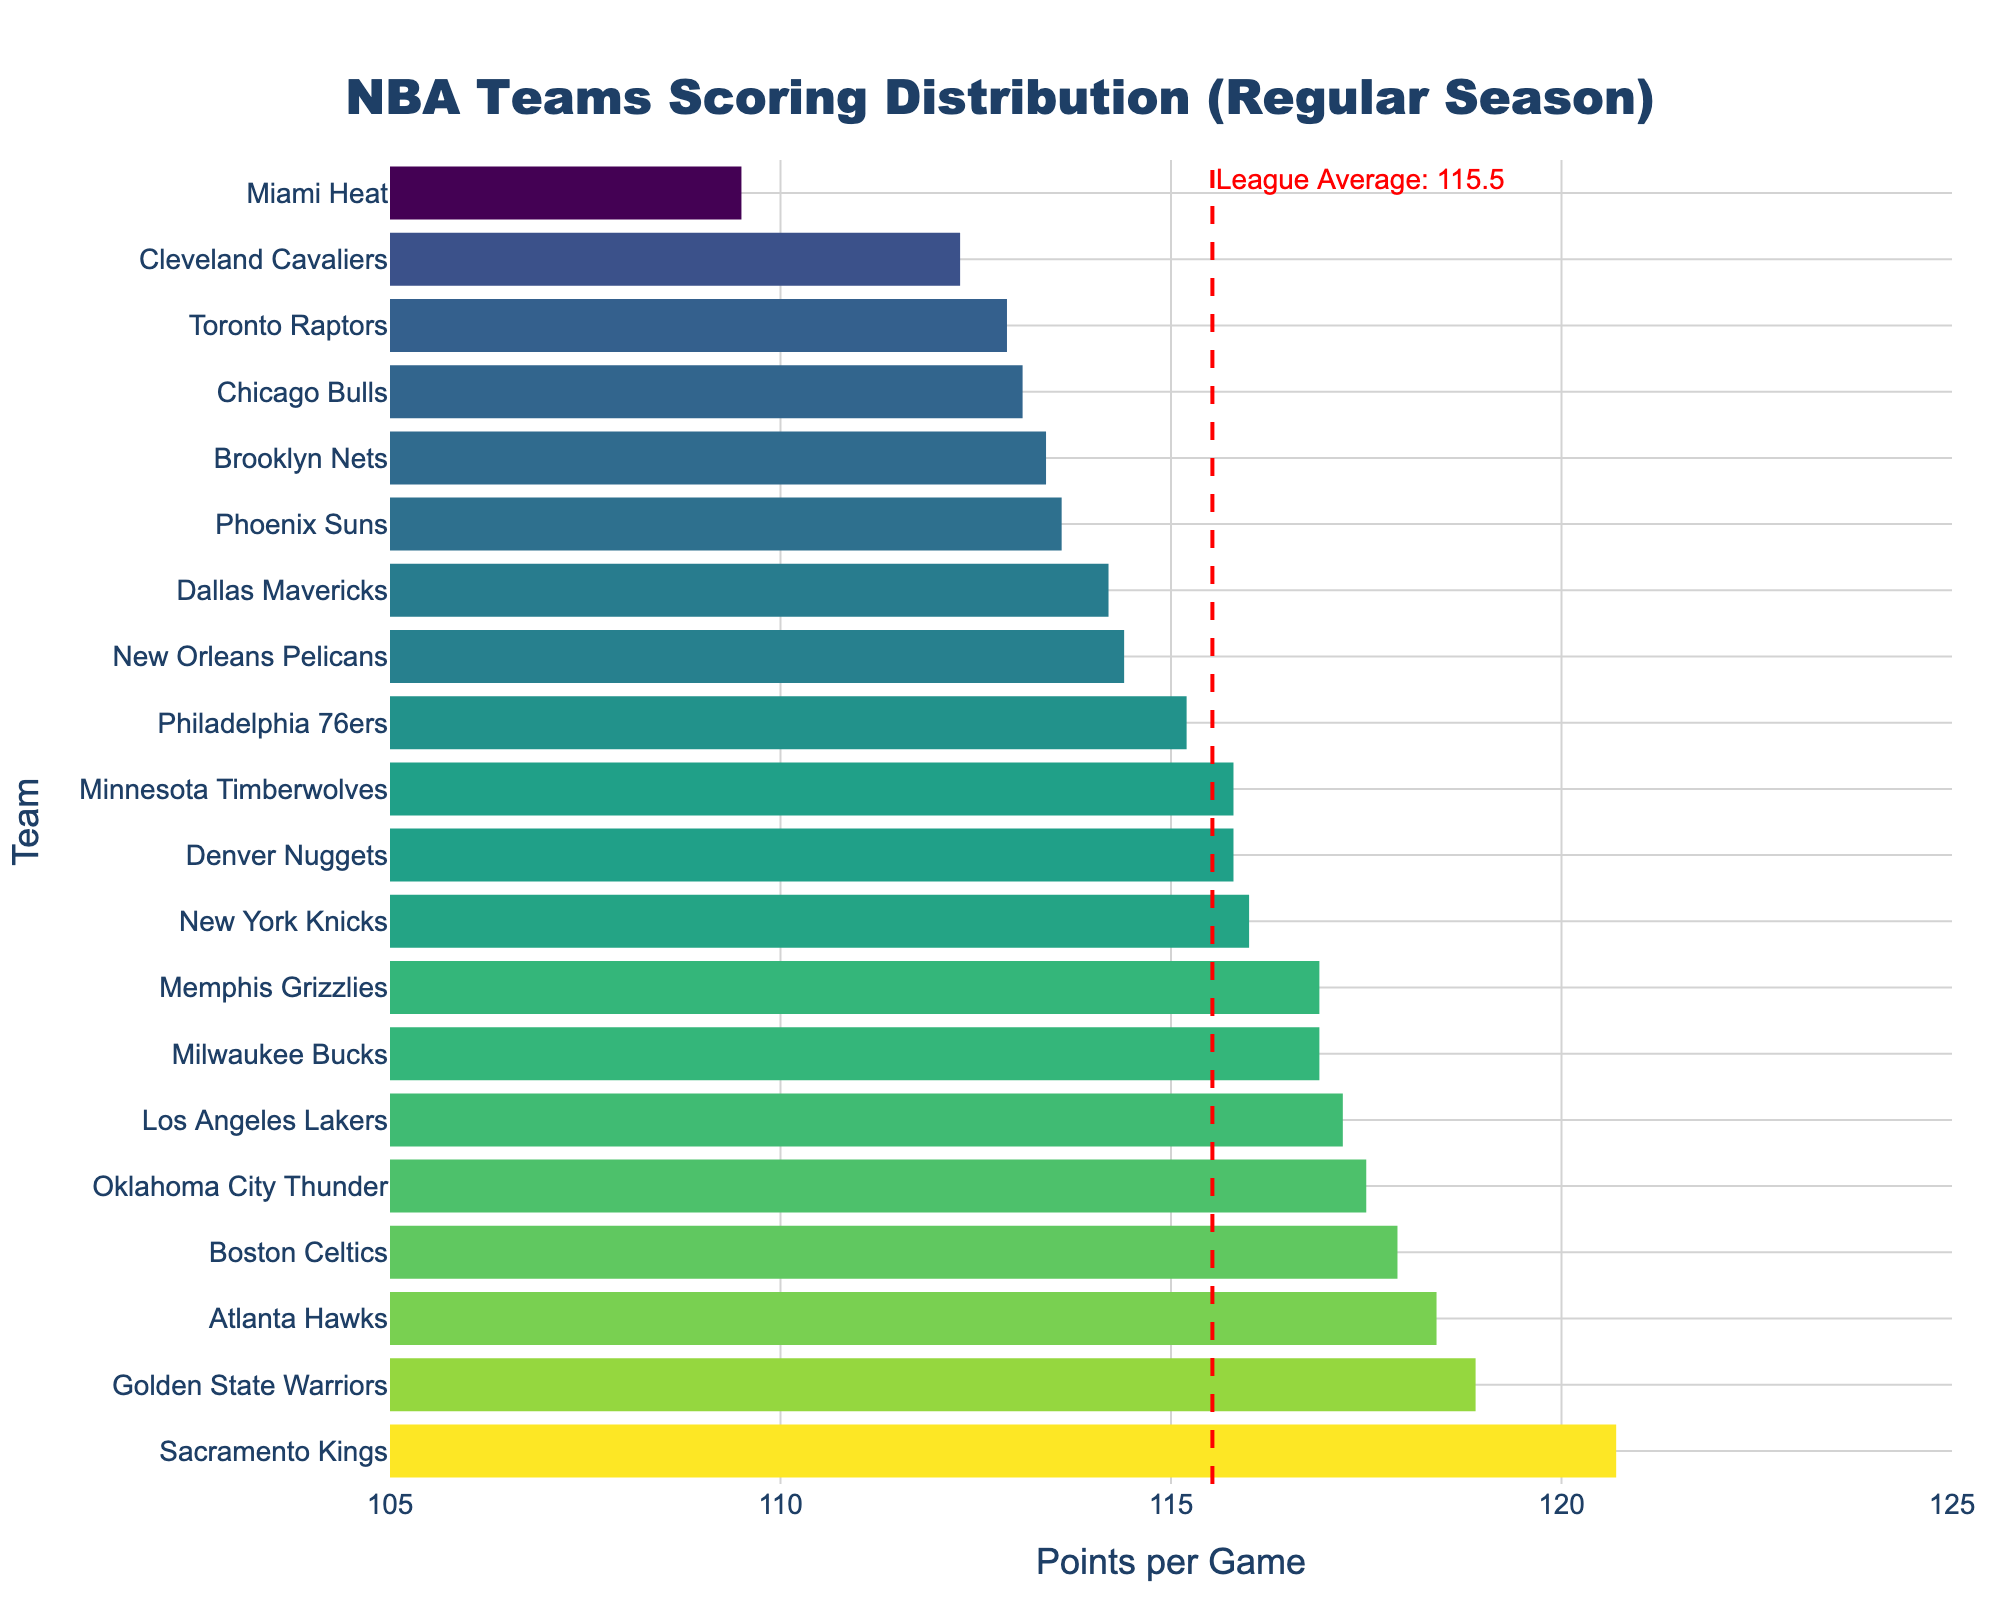What is the title of the figure? The title is usually found at the top of the plot. It provides context about what the figure represents. In this case, the title is "NBA Teams Scoring Distribution (Regular Season)."
Answer: NBA Teams Scoring Distribution (Regular Season) Which team has the highest points per game? To identify the team with the highest points per game, look at the horizontal bars to see which one extends the farthest to the right. The Sacramento Kings have the longest bar.
Answer: Sacramento Kings What is the average points per game across all teams? The average points per game is indicated by the vertical dashed red line. The annotation near this line reads "League Average: 114.8."
Answer: 114.8 How many teams score above the league average points per game? To find this, count the number of bars that extend beyond the vertical line representing the league average of 114.8 points per game. There are 10 teams that score above this average.
Answer: 10 Which team has the lowest points per game, and what is their score? The team with the shortest bar has the lowest points per game. The Miami Heat have the shortest bar, indicating their points per game. According to the hover text, they score 109.5 points per game.
Answer: Miami Heat, 109.5 Are the Golden State Warriors scoring more or less than the Boston Celtics? Compare the lengths of the bars for both teams. The Golden State Warriors have a bar extending to 118.9, while the Boston Celtics' bar extends to 117.9. Thus, the Warriors score more.
Answer: More What is the difference in points per game between the Philadelphia 76ers and the Memphis Grizzlies? The points per game for the Philadelphia 76ers is 115.2 and for the Memphis Grizzlies is 116.9. The difference can be calculated as 116.9 - 115.2 = 1.7 points per game.
Answer: 1.7 Which teams score closest to the average points per game? Identify the teams whose bars are nearest to the red vertical average line. The Dallas Mavericks (114.2) and the New Orleans Pelicans (114.4) are the two closest to the average of 114.8.
Answer: Dallas Mavericks, New Orleans Pelicans Which team has a higher points per game: New York Knicks or Phoenix Suns? Compare the lengths of the bars for both teams. The New York Knicks score 116.0 points per game, and the Phoenix Suns score 113.6 points per game. Therefore, the Knicks have a higher score.
Answer: New York Knicks 